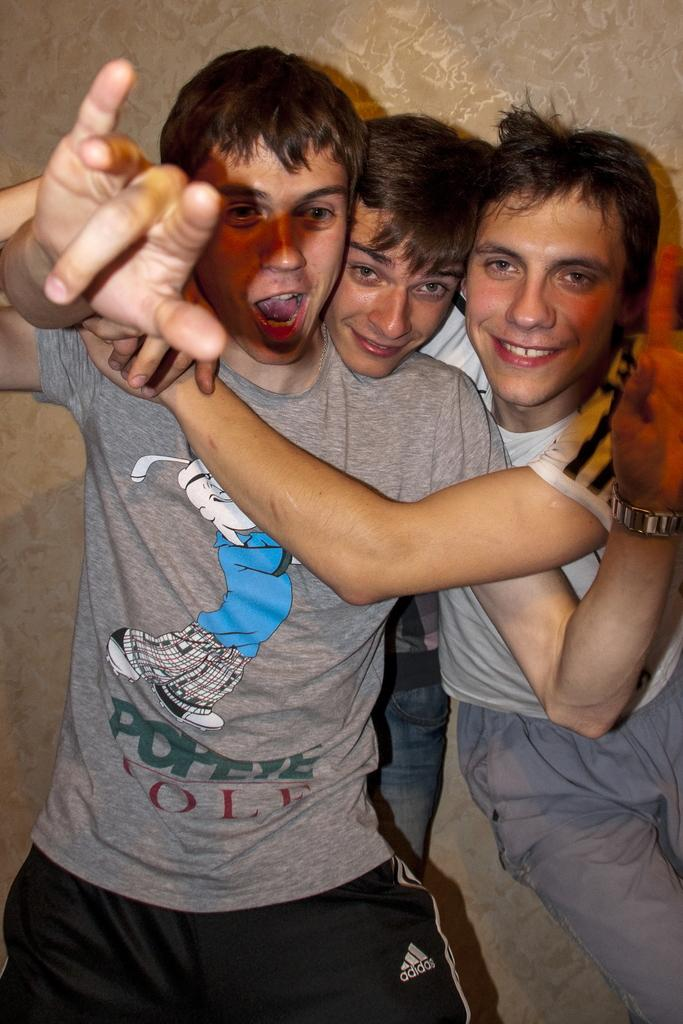<image>
Relay a brief, clear account of the picture shown. Three guys are embracing and one of them is wearing a Popeye shirt. 